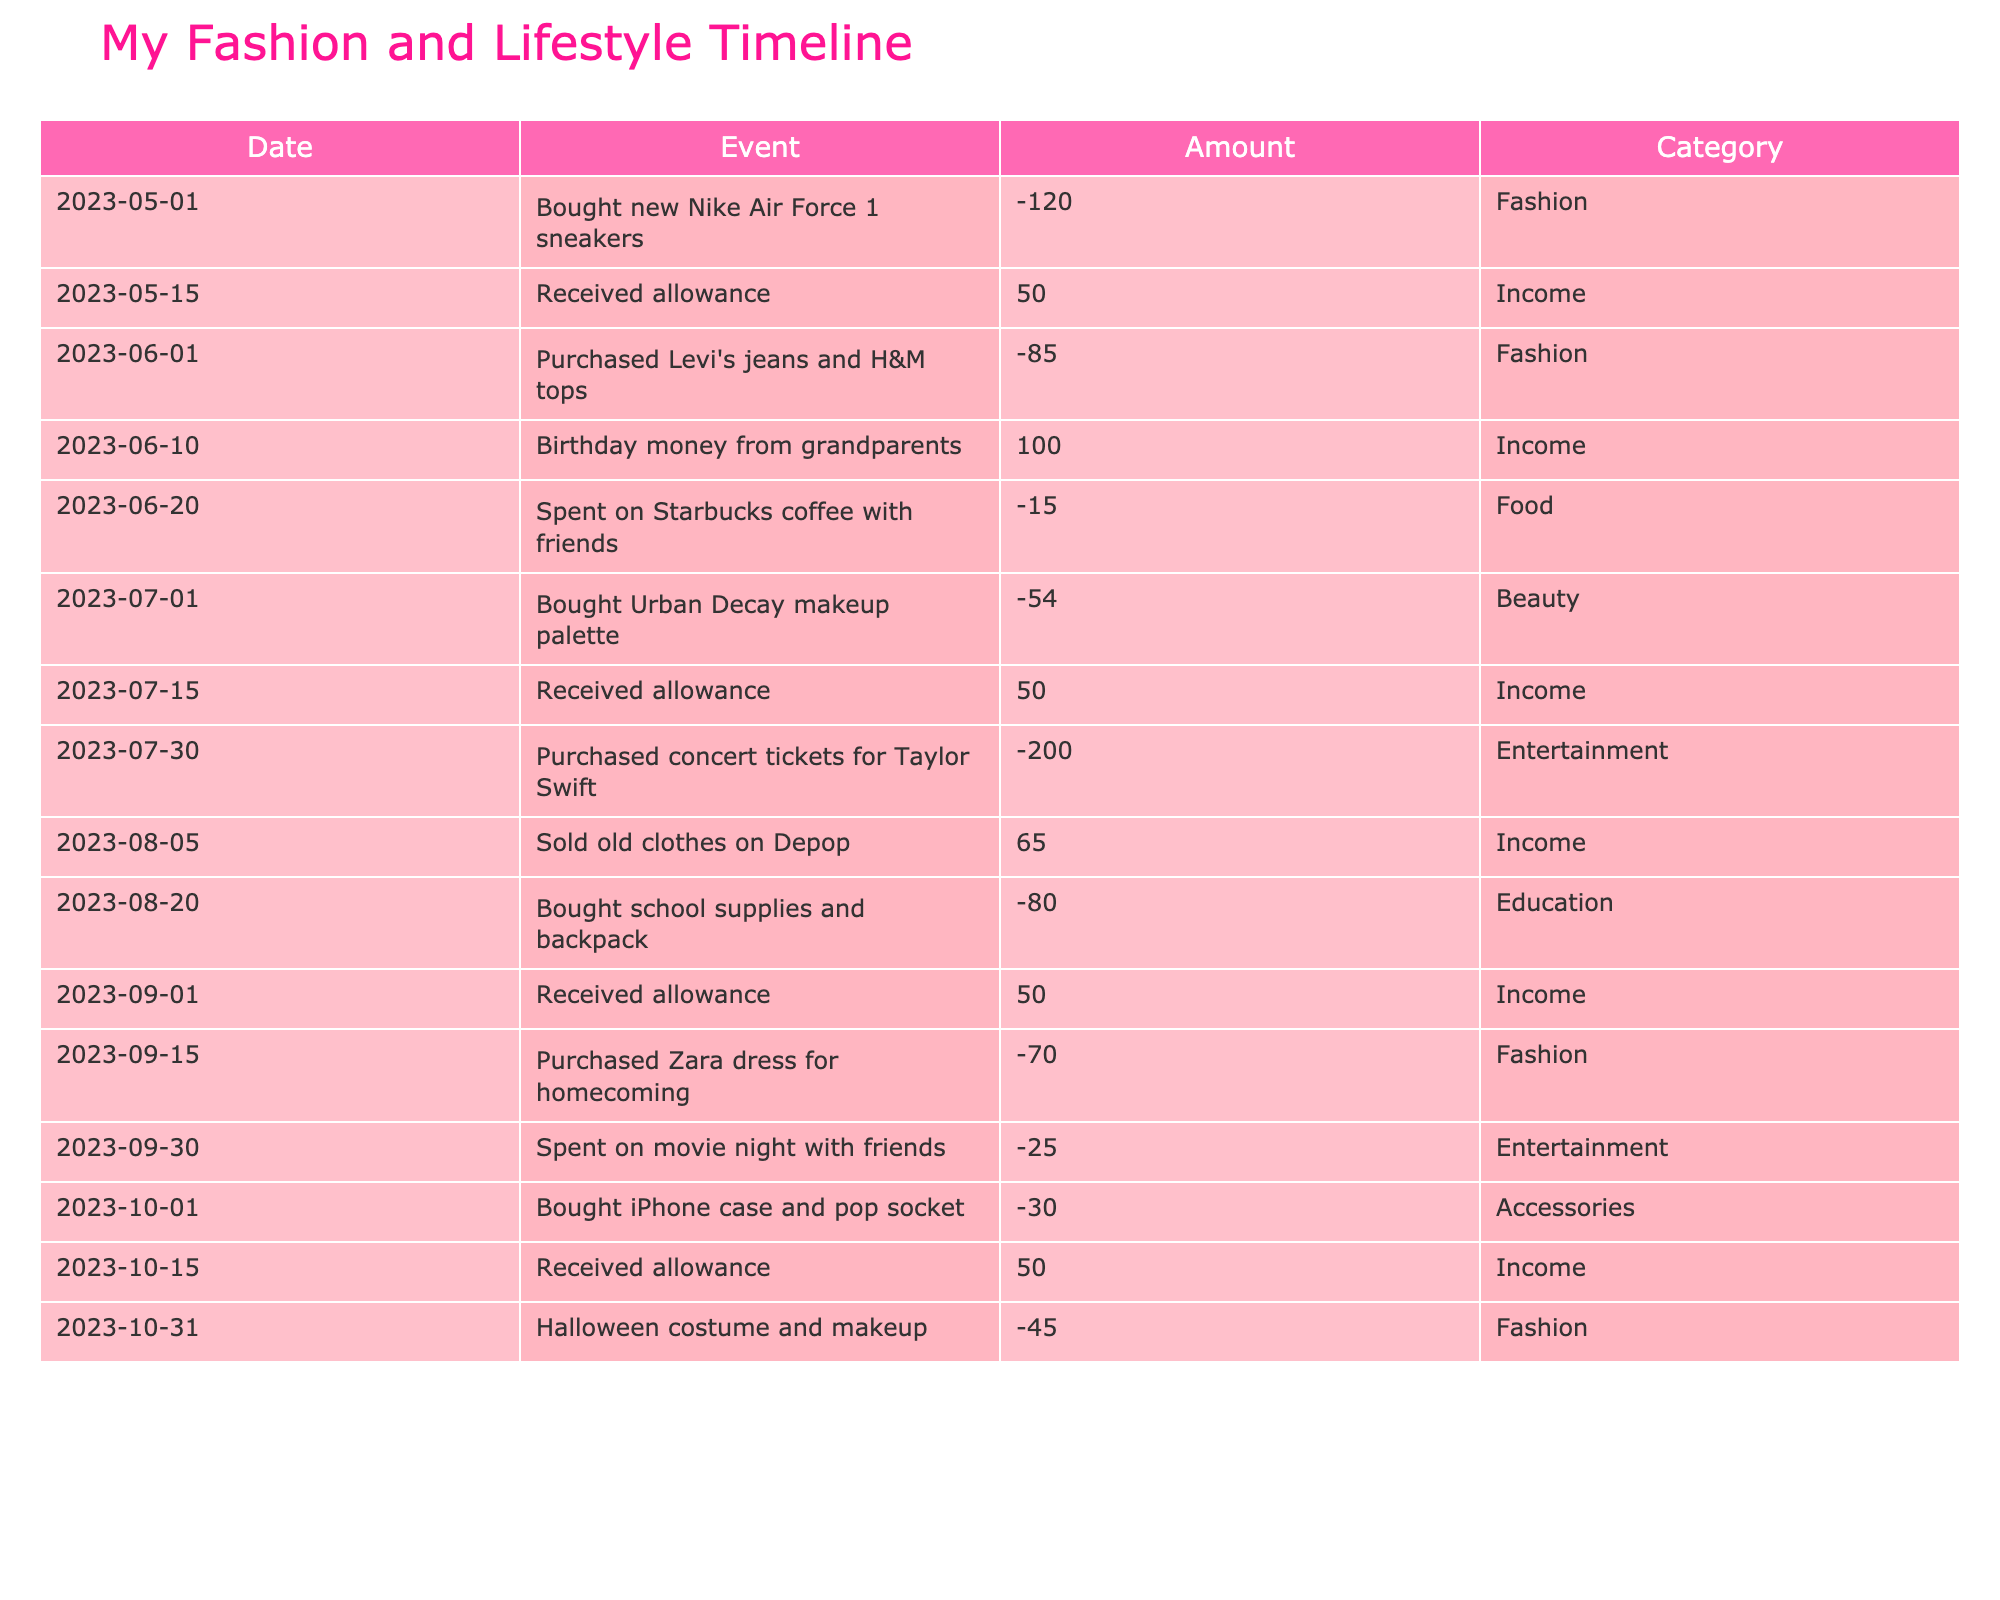What was the total amount spent on fashion items? To find the total amount spent on fashion items, we look for all entries in the 'Fashion' category and sum their amounts: -120 (sneakers) + -85 (jeans and tops) + -70 (Zara dress) + -45 (Halloween costume) = -320. The total spent on fashion is $320.
Answer: 320 How much allowance did you receive in total over the six months? We need to find all entries where the category is 'Income' and the amount is positive. The allowance entries are: +50 (May) +50 (July) +50 (September) +50 (October) = 200. The total allowance received is $200.
Answer: 200 Did you spend more on entertainment or fashion? To answer this, we need to sum the total amount for each category. For entertainment: -200 (concert tickets) + -25 (movie night) = -225. For fashion: -120 (sneakers) + -85 (jeans and tops) + -70 (Zara dress) + -45 (Halloween costume) = -320. Since -225 is greater than -320, you spent more on fashion than on entertainment.
Answer: No What percentage of your total spending in these six months is on food? First, we need the total spent and the total spent on food. The total spending is calculated as follows: -120 (sneakers) + -85 (jeans and tops) + -15 (Starbucks coffee) + -54 (makeup) + -200 (concert tickets) + -80 (school supplies) + -70 (Zara dress) + -25 (movie night) + -30 (iPhone case) + -45 (costume) = -404. The only food expense is -15 from coffee with friends. Therefore, the percentage is (-15 / -404) * 100 = 3.71%.
Answer: 3.71% What was your overall savings after six months? To find overall savings, we sum all the income and expenses. Total income: +50 (May) +100 (birthday money) +50 (July) +65 (sold clothes) +50 (September) +50 (October) = 365. Total expenses: -120 -85 -15 -54 -200 -80 -70 -25 -30 -45 = -404. Thus, overall savings are calculated as 365 (income) - 404 (expenses) = -39. This means you spent $39 more than you earned.
Answer: -39 